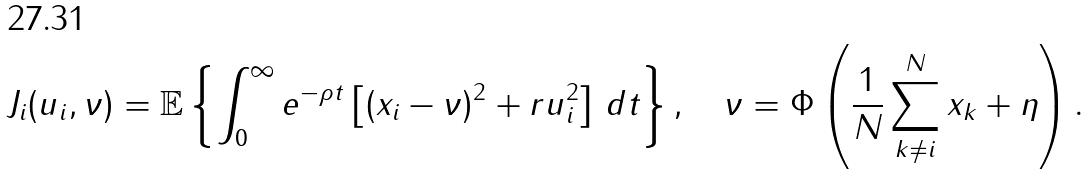<formula> <loc_0><loc_0><loc_500><loc_500>J _ { i } ( u _ { i } , \nu ) = \mathbb { E } \left \{ \int _ { 0 } ^ { \infty } e ^ { - \rho t } \left [ ( x _ { i } - \nu ) ^ { 2 } + r u _ { i } ^ { 2 } \right ] \, d t \right \} , \quad \nu = \Phi \left ( { \frac { 1 } { N } } \sum _ { k \neq i } ^ { N } x _ { k } + \eta \right ) .</formula> 